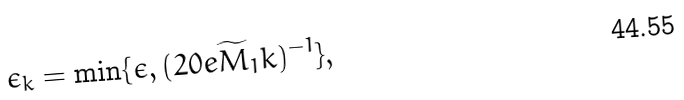Convert formula to latex. <formula><loc_0><loc_0><loc_500><loc_500>\epsilon _ { k } = \min \{ \epsilon , ( 2 0 e \widetilde { M } _ { 1 } k ) ^ { - 1 } \} ,</formula> 